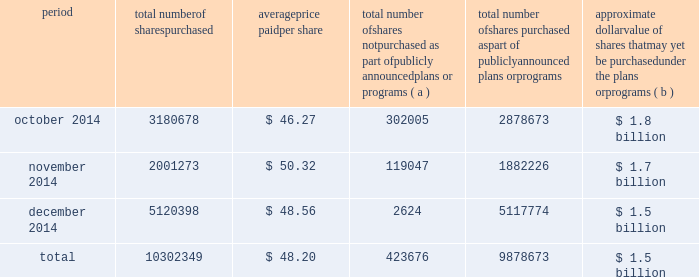The table discloses purchases of shares of valero 2019s common stock made by us or on our behalf during the fourth quarter of period total number of shares purchased average price paid per share total number of shares not purchased as part of publicly announced plans or programs ( a ) total number of shares purchased as part of publicly announced plans or programs approximate dollar value of shares that may yet be purchased under the plans or programs ( b ) .
( a ) the shares reported in this column represent purchases settled in the fourth quarter of 2014 relating to ( i ) our purchases of shares in open-market transactions to meet our obligations under stock-based compensation plans , and ( ii ) our purchases of shares from our employees and non-employee directors in connection with the exercise of stock options , the vesting of restricted stock , and other stock compensation transactions in accordance with the terms of our stock-based compensation plans .
( b ) on february 28 , 2008 , we announced that our board of directors approved a $ 3 billion common stock purchase program .
This $ 3 billion program has no expiration date. .
How many more shares were purchased as part of publicly announced plans in december 2014 than october 2014? 
Computations: (5117774 - 2878673)
Answer: 2239101.0. 